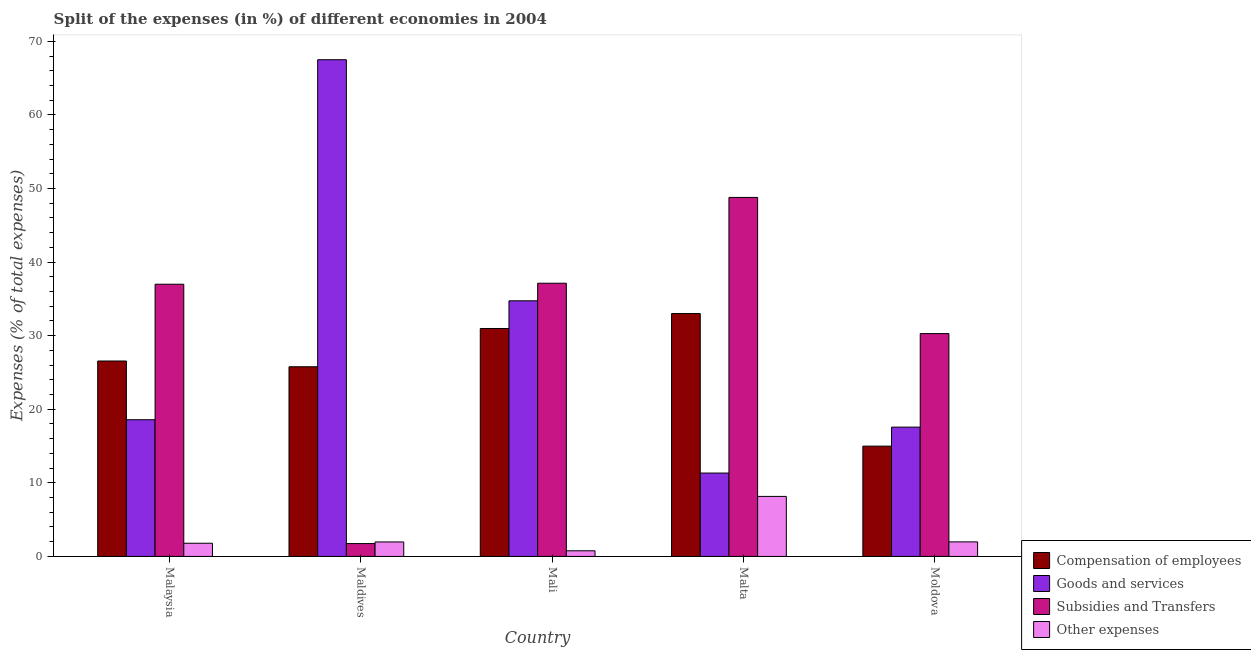How many different coloured bars are there?
Make the answer very short. 4. How many groups of bars are there?
Your response must be concise. 5. Are the number of bars on each tick of the X-axis equal?
Offer a terse response. Yes. How many bars are there on the 5th tick from the left?
Make the answer very short. 4. What is the label of the 3rd group of bars from the left?
Your answer should be very brief. Mali. In how many cases, is the number of bars for a given country not equal to the number of legend labels?
Offer a terse response. 0. What is the percentage of amount spent on other expenses in Malta?
Your response must be concise. 8.16. Across all countries, what is the maximum percentage of amount spent on goods and services?
Make the answer very short. 67.5. Across all countries, what is the minimum percentage of amount spent on other expenses?
Keep it short and to the point. 0.77. In which country was the percentage of amount spent on other expenses maximum?
Ensure brevity in your answer.  Malta. In which country was the percentage of amount spent on goods and services minimum?
Your answer should be compact. Malta. What is the total percentage of amount spent on subsidies in the graph?
Offer a terse response. 154.94. What is the difference between the percentage of amount spent on goods and services in Malaysia and that in Moldova?
Make the answer very short. 1. What is the difference between the percentage of amount spent on compensation of employees in Moldova and the percentage of amount spent on subsidies in Malta?
Give a very brief answer. -33.8. What is the average percentage of amount spent on other expenses per country?
Offer a terse response. 2.93. What is the difference between the percentage of amount spent on compensation of employees and percentage of amount spent on other expenses in Mali?
Your response must be concise. 30.21. In how many countries, is the percentage of amount spent on goods and services greater than 12 %?
Provide a short and direct response. 4. What is the ratio of the percentage of amount spent on goods and services in Maldives to that in Moldova?
Your answer should be compact. 3.84. Is the difference between the percentage of amount spent on compensation of employees in Maldives and Mali greater than the difference between the percentage of amount spent on goods and services in Maldives and Mali?
Provide a short and direct response. No. What is the difference between the highest and the second highest percentage of amount spent on compensation of employees?
Your response must be concise. 2.03. What is the difference between the highest and the lowest percentage of amount spent on goods and services?
Your answer should be compact. 56.17. What does the 1st bar from the left in Moldova represents?
Give a very brief answer. Compensation of employees. What does the 3rd bar from the right in Mali represents?
Give a very brief answer. Goods and services. How many bars are there?
Keep it short and to the point. 20. Does the graph contain any zero values?
Make the answer very short. No. How many legend labels are there?
Make the answer very short. 4. How are the legend labels stacked?
Offer a very short reply. Vertical. What is the title of the graph?
Your response must be concise. Split of the expenses (in %) of different economies in 2004. What is the label or title of the X-axis?
Keep it short and to the point. Country. What is the label or title of the Y-axis?
Offer a terse response. Expenses (% of total expenses). What is the Expenses (% of total expenses) in Compensation of employees in Malaysia?
Your answer should be compact. 26.56. What is the Expenses (% of total expenses) in Goods and services in Malaysia?
Offer a very short reply. 18.58. What is the Expenses (% of total expenses) in Subsidies and Transfers in Malaysia?
Provide a short and direct response. 36.99. What is the Expenses (% of total expenses) of Other expenses in Malaysia?
Make the answer very short. 1.79. What is the Expenses (% of total expenses) in Compensation of employees in Maldives?
Offer a terse response. 25.78. What is the Expenses (% of total expenses) in Goods and services in Maldives?
Keep it short and to the point. 67.5. What is the Expenses (% of total expenses) of Subsidies and Transfers in Maldives?
Provide a short and direct response. 1.75. What is the Expenses (% of total expenses) in Other expenses in Maldives?
Offer a very short reply. 1.97. What is the Expenses (% of total expenses) of Compensation of employees in Mali?
Offer a very short reply. 30.98. What is the Expenses (% of total expenses) in Goods and services in Mali?
Provide a short and direct response. 34.74. What is the Expenses (% of total expenses) in Subsidies and Transfers in Mali?
Provide a succinct answer. 37.13. What is the Expenses (% of total expenses) of Other expenses in Mali?
Keep it short and to the point. 0.77. What is the Expenses (% of total expenses) of Compensation of employees in Malta?
Your answer should be very brief. 33.01. What is the Expenses (% of total expenses) in Goods and services in Malta?
Offer a terse response. 11.33. What is the Expenses (% of total expenses) in Subsidies and Transfers in Malta?
Keep it short and to the point. 48.79. What is the Expenses (% of total expenses) of Other expenses in Malta?
Your answer should be compact. 8.16. What is the Expenses (% of total expenses) of Compensation of employees in Moldova?
Give a very brief answer. 14.99. What is the Expenses (% of total expenses) in Goods and services in Moldova?
Offer a terse response. 17.57. What is the Expenses (% of total expenses) of Subsidies and Transfers in Moldova?
Keep it short and to the point. 30.29. What is the Expenses (% of total expenses) of Other expenses in Moldova?
Keep it short and to the point. 1.98. Across all countries, what is the maximum Expenses (% of total expenses) of Compensation of employees?
Your answer should be compact. 33.01. Across all countries, what is the maximum Expenses (% of total expenses) in Goods and services?
Your response must be concise. 67.5. Across all countries, what is the maximum Expenses (% of total expenses) in Subsidies and Transfers?
Your answer should be very brief. 48.79. Across all countries, what is the maximum Expenses (% of total expenses) in Other expenses?
Keep it short and to the point. 8.16. Across all countries, what is the minimum Expenses (% of total expenses) of Compensation of employees?
Provide a succinct answer. 14.99. Across all countries, what is the minimum Expenses (% of total expenses) in Goods and services?
Ensure brevity in your answer.  11.33. Across all countries, what is the minimum Expenses (% of total expenses) of Subsidies and Transfers?
Give a very brief answer. 1.75. Across all countries, what is the minimum Expenses (% of total expenses) in Other expenses?
Give a very brief answer. 0.77. What is the total Expenses (% of total expenses) of Compensation of employees in the graph?
Give a very brief answer. 131.31. What is the total Expenses (% of total expenses) of Goods and services in the graph?
Your answer should be very brief. 149.73. What is the total Expenses (% of total expenses) of Subsidies and Transfers in the graph?
Provide a short and direct response. 154.94. What is the total Expenses (% of total expenses) of Other expenses in the graph?
Provide a short and direct response. 14.66. What is the difference between the Expenses (% of total expenses) of Compensation of employees in Malaysia and that in Maldives?
Keep it short and to the point. 0.78. What is the difference between the Expenses (% of total expenses) of Goods and services in Malaysia and that in Maldives?
Provide a short and direct response. -48.93. What is the difference between the Expenses (% of total expenses) of Subsidies and Transfers in Malaysia and that in Maldives?
Your response must be concise. 35.25. What is the difference between the Expenses (% of total expenses) in Other expenses in Malaysia and that in Maldives?
Offer a terse response. -0.18. What is the difference between the Expenses (% of total expenses) of Compensation of employees in Malaysia and that in Mali?
Make the answer very short. -4.42. What is the difference between the Expenses (% of total expenses) of Goods and services in Malaysia and that in Mali?
Provide a short and direct response. -16.16. What is the difference between the Expenses (% of total expenses) in Subsidies and Transfers in Malaysia and that in Mali?
Provide a succinct answer. -0.14. What is the difference between the Expenses (% of total expenses) of Other expenses in Malaysia and that in Mali?
Offer a very short reply. 1.02. What is the difference between the Expenses (% of total expenses) of Compensation of employees in Malaysia and that in Malta?
Give a very brief answer. -6.45. What is the difference between the Expenses (% of total expenses) of Goods and services in Malaysia and that in Malta?
Offer a very short reply. 7.25. What is the difference between the Expenses (% of total expenses) of Subsidies and Transfers in Malaysia and that in Malta?
Provide a short and direct response. -11.8. What is the difference between the Expenses (% of total expenses) in Other expenses in Malaysia and that in Malta?
Provide a succinct answer. -6.36. What is the difference between the Expenses (% of total expenses) of Compensation of employees in Malaysia and that in Moldova?
Your answer should be compact. 11.57. What is the difference between the Expenses (% of total expenses) in Subsidies and Transfers in Malaysia and that in Moldova?
Ensure brevity in your answer.  6.71. What is the difference between the Expenses (% of total expenses) of Other expenses in Malaysia and that in Moldova?
Give a very brief answer. -0.18. What is the difference between the Expenses (% of total expenses) of Goods and services in Maldives and that in Mali?
Provide a succinct answer. 32.76. What is the difference between the Expenses (% of total expenses) in Subsidies and Transfers in Maldives and that in Mali?
Offer a very short reply. -35.38. What is the difference between the Expenses (% of total expenses) in Other expenses in Maldives and that in Mali?
Provide a short and direct response. 1.2. What is the difference between the Expenses (% of total expenses) in Compensation of employees in Maldives and that in Malta?
Your answer should be compact. -7.23. What is the difference between the Expenses (% of total expenses) of Goods and services in Maldives and that in Malta?
Offer a terse response. 56.17. What is the difference between the Expenses (% of total expenses) of Subsidies and Transfers in Maldives and that in Malta?
Offer a very short reply. -47.04. What is the difference between the Expenses (% of total expenses) of Other expenses in Maldives and that in Malta?
Your answer should be compact. -6.19. What is the difference between the Expenses (% of total expenses) of Compensation of employees in Maldives and that in Moldova?
Make the answer very short. 10.79. What is the difference between the Expenses (% of total expenses) of Goods and services in Maldives and that in Moldova?
Give a very brief answer. 49.93. What is the difference between the Expenses (% of total expenses) of Subsidies and Transfers in Maldives and that in Moldova?
Ensure brevity in your answer.  -28.54. What is the difference between the Expenses (% of total expenses) in Other expenses in Maldives and that in Moldova?
Your response must be concise. -0.01. What is the difference between the Expenses (% of total expenses) in Compensation of employees in Mali and that in Malta?
Your answer should be very brief. -2.03. What is the difference between the Expenses (% of total expenses) in Goods and services in Mali and that in Malta?
Keep it short and to the point. 23.41. What is the difference between the Expenses (% of total expenses) in Subsidies and Transfers in Mali and that in Malta?
Make the answer very short. -11.66. What is the difference between the Expenses (% of total expenses) of Other expenses in Mali and that in Malta?
Ensure brevity in your answer.  -7.39. What is the difference between the Expenses (% of total expenses) in Compensation of employees in Mali and that in Moldova?
Make the answer very short. 15.99. What is the difference between the Expenses (% of total expenses) in Goods and services in Mali and that in Moldova?
Your response must be concise. 17.17. What is the difference between the Expenses (% of total expenses) in Subsidies and Transfers in Mali and that in Moldova?
Your answer should be very brief. 6.84. What is the difference between the Expenses (% of total expenses) in Other expenses in Mali and that in Moldova?
Provide a short and direct response. -1.21. What is the difference between the Expenses (% of total expenses) of Compensation of employees in Malta and that in Moldova?
Offer a terse response. 18.02. What is the difference between the Expenses (% of total expenses) of Goods and services in Malta and that in Moldova?
Your answer should be compact. -6.24. What is the difference between the Expenses (% of total expenses) in Subsidies and Transfers in Malta and that in Moldova?
Offer a very short reply. 18.5. What is the difference between the Expenses (% of total expenses) of Other expenses in Malta and that in Moldova?
Make the answer very short. 6.18. What is the difference between the Expenses (% of total expenses) in Compensation of employees in Malaysia and the Expenses (% of total expenses) in Goods and services in Maldives?
Make the answer very short. -40.95. What is the difference between the Expenses (% of total expenses) of Compensation of employees in Malaysia and the Expenses (% of total expenses) of Subsidies and Transfers in Maldives?
Your answer should be very brief. 24.81. What is the difference between the Expenses (% of total expenses) in Compensation of employees in Malaysia and the Expenses (% of total expenses) in Other expenses in Maldives?
Give a very brief answer. 24.59. What is the difference between the Expenses (% of total expenses) of Goods and services in Malaysia and the Expenses (% of total expenses) of Subsidies and Transfers in Maldives?
Give a very brief answer. 16.83. What is the difference between the Expenses (% of total expenses) in Goods and services in Malaysia and the Expenses (% of total expenses) in Other expenses in Maldives?
Provide a short and direct response. 16.61. What is the difference between the Expenses (% of total expenses) of Subsidies and Transfers in Malaysia and the Expenses (% of total expenses) of Other expenses in Maldives?
Keep it short and to the point. 35.02. What is the difference between the Expenses (% of total expenses) in Compensation of employees in Malaysia and the Expenses (% of total expenses) in Goods and services in Mali?
Give a very brief answer. -8.18. What is the difference between the Expenses (% of total expenses) of Compensation of employees in Malaysia and the Expenses (% of total expenses) of Subsidies and Transfers in Mali?
Provide a short and direct response. -10.57. What is the difference between the Expenses (% of total expenses) of Compensation of employees in Malaysia and the Expenses (% of total expenses) of Other expenses in Mali?
Ensure brevity in your answer.  25.79. What is the difference between the Expenses (% of total expenses) in Goods and services in Malaysia and the Expenses (% of total expenses) in Subsidies and Transfers in Mali?
Make the answer very short. -18.55. What is the difference between the Expenses (% of total expenses) of Goods and services in Malaysia and the Expenses (% of total expenses) of Other expenses in Mali?
Your answer should be compact. 17.81. What is the difference between the Expenses (% of total expenses) of Subsidies and Transfers in Malaysia and the Expenses (% of total expenses) of Other expenses in Mali?
Provide a short and direct response. 36.22. What is the difference between the Expenses (% of total expenses) in Compensation of employees in Malaysia and the Expenses (% of total expenses) in Goods and services in Malta?
Keep it short and to the point. 15.23. What is the difference between the Expenses (% of total expenses) in Compensation of employees in Malaysia and the Expenses (% of total expenses) in Subsidies and Transfers in Malta?
Offer a very short reply. -22.23. What is the difference between the Expenses (% of total expenses) of Compensation of employees in Malaysia and the Expenses (% of total expenses) of Other expenses in Malta?
Make the answer very short. 18.4. What is the difference between the Expenses (% of total expenses) of Goods and services in Malaysia and the Expenses (% of total expenses) of Subsidies and Transfers in Malta?
Keep it short and to the point. -30.21. What is the difference between the Expenses (% of total expenses) in Goods and services in Malaysia and the Expenses (% of total expenses) in Other expenses in Malta?
Your answer should be compact. 10.42. What is the difference between the Expenses (% of total expenses) in Subsidies and Transfers in Malaysia and the Expenses (% of total expenses) in Other expenses in Malta?
Offer a terse response. 28.84. What is the difference between the Expenses (% of total expenses) of Compensation of employees in Malaysia and the Expenses (% of total expenses) of Goods and services in Moldova?
Offer a terse response. 8.98. What is the difference between the Expenses (% of total expenses) of Compensation of employees in Malaysia and the Expenses (% of total expenses) of Subsidies and Transfers in Moldova?
Offer a terse response. -3.73. What is the difference between the Expenses (% of total expenses) of Compensation of employees in Malaysia and the Expenses (% of total expenses) of Other expenses in Moldova?
Provide a succinct answer. 24.58. What is the difference between the Expenses (% of total expenses) of Goods and services in Malaysia and the Expenses (% of total expenses) of Subsidies and Transfers in Moldova?
Offer a very short reply. -11.71. What is the difference between the Expenses (% of total expenses) in Goods and services in Malaysia and the Expenses (% of total expenses) in Other expenses in Moldova?
Your answer should be compact. 16.6. What is the difference between the Expenses (% of total expenses) in Subsidies and Transfers in Malaysia and the Expenses (% of total expenses) in Other expenses in Moldova?
Make the answer very short. 35.02. What is the difference between the Expenses (% of total expenses) in Compensation of employees in Maldives and the Expenses (% of total expenses) in Goods and services in Mali?
Offer a terse response. -8.96. What is the difference between the Expenses (% of total expenses) in Compensation of employees in Maldives and the Expenses (% of total expenses) in Subsidies and Transfers in Mali?
Offer a very short reply. -11.35. What is the difference between the Expenses (% of total expenses) in Compensation of employees in Maldives and the Expenses (% of total expenses) in Other expenses in Mali?
Your answer should be compact. 25.01. What is the difference between the Expenses (% of total expenses) of Goods and services in Maldives and the Expenses (% of total expenses) of Subsidies and Transfers in Mali?
Provide a succinct answer. 30.38. What is the difference between the Expenses (% of total expenses) of Goods and services in Maldives and the Expenses (% of total expenses) of Other expenses in Mali?
Offer a very short reply. 66.74. What is the difference between the Expenses (% of total expenses) of Subsidies and Transfers in Maldives and the Expenses (% of total expenses) of Other expenses in Mali?
Provide a short and direct response. 0.98. What is the difference between the Expenses (% of total expenses) in Compensation of employees in Maldives and the Expenses (% of total expenses) in Goods and services in Malta?
Make the answer very short. 14.45. What is the difference between the Expenses (% of total expenses) in Compensation of employees in Maldives and the Expenses (% of total expenses) in Subsidies and Transfers in Malta?
Your response must be concise. -23.01. What is the difference between the Expenses (% of total expenses) in Compensation of employees in Maldives and the Expenses (% of total expenses) in Other expenses in Malta?
Your answer should be very brief. 17.62. What is the difference between the Expenses (% of total expenses) of Goods and services in Maldives and the Expenses (% of total expenses) of Subsidies and Transfers in Malta?
Make the answer very short. 18.72. What is the difference between the Expenses (% of total expenses) of Goods and services in Maldives and the Expenses (% of total expenses) of Other expenses in Malta?
Keep it short and to the point. 59.35. What is the difference between the Expenses (% of total expenses) of Subsidies and Transfers in Maldives and the Expenses (% of total expenses) of Other expenses in Malta?
Give a very brief answer. -6.41. What is the difference between the Expenses (% of total expenses) in Compensation of employees in Maldives and the Expenses (% of total expenses) in Goods and services in Moldova?
Offer a very short reply. 8.2. What is the difference between the Expenses (% of total expenses) in Compensation of employees in Maldives and the Expenses (% of total expenses) in Subsidies and Transfers in Moldova?
Make the answer very short. -4.51. What is the difference between the Expenses (% of total expenses) in Compensation of employees in Maldives and the Expenses (% of total expenses) in Other expenses in Moldova?
Ensure brevity in your answer.  23.8. What is the difference between the Expenses (% of total expenses) of Goods and services in Maldives and the Expenses (% of total expenses) of Subsidies and Transfers in Moldova?
Make the answer very short. 37.22. What is the difference between the Expenses (% of total expenses) of Goods and services in Maldives and the Expenses (% of total expenses) of Other expenses in Moldova?
Give a very brief answer. 65.53. What is the difference between the Expenses (% of total expenses) in Subsidies and Transfers in Maldives and the Expenses (% of total expenses) in Other expenses in Moldova?
Your answer should be compact. -0.23. What is the difference between the Expenses (% of total expenses) of Compensation of employees in Mali and the Expenses (% of total expenses) of Goods and services in Malta?
Make the answer very short. 19.65. What is the difference between the Expenses (% of total expenses) of Compensation of employees in Mali and the Expenses (% of total expenses) of Subsidies and Transfers in Malta?
Keep it short and to the point. -17.81. What is the difference between the Expenses (% of total expenses) in Compensation of employees in Mali and the Expenses (% of total expenses) in Other expenses in Malta?
Offer a very short reply. 22.82. What is the difference between the Expenses (% of total expenses) in Goods and services in Mali and the Expenses (% of total expenses) in Subsidies and Transfers in Malta?
Provide a short and direct response. -14.05. What is the difference between the Expenses (% of total expenses) of Goods and services in Mali and the Expenses (% of total expenses) of Other expenses in Malta?
Make the answer very short. 26.58. What is the difference between the Expenses (% of total expenses) of Subsidies and Transfers in Mali and the Expenses (% of total expenses) of Other expenses in Malta?
Offer a terse response. 28.97. What is the difference between the Expenses (% of total expenses) in Compensation of employees in Mali and the Expenses (% of total expenses) in Goods and services in Moldova?
Keep it short and to the point. 13.4. What is the difference between the Expenses (% of total expenses) of Compensation of employees in Mali and the Expenses (% of total expenses) of Subsidies and Transfers in Moldova?
Provide a short and direct response. 0.69. What is the difference between the Expenses (% of total expenses) in Compensation of employees in Mali and the Expenses (% of total expenses) in Other expenses in Moldova?
Your answer should be compact. 29. What is the difference between the Expenses (% of total expenses) of Goods and services in Mali and the Expenses (% of total expenses) of Subsidies and Transfers in Moldova?
Provide a short and direct response. 4.45. What is the difference between the Expenses (% of total expenses) in Goods and services in Mali and the Expenses (% of total expenses) in Other expenses in Moldova?
Provide a short and direct response. 32.76. What is the difference between the Expenses (% of total expenses) of Subsidies and Transfers in Mali and the Expenses (% of total expenses) of Other expenses in Moldova?
Make the answer very short. 35.15. What is the difference between the Expenses (% of total expenses) of Compensation of employees in Malta and the Expenses (% of total expenses) of Goods and services in Moldova?
Your answer should be very brief. 15.44. What is the difference between the Expenses (% of total expenses) in Compensation of employees in Malta and the Expenses (% of total expenses) in Subsidies and Transfers in Moldova?
Give a very brief answer. 2.72. What is the difference between the Expenses (% of total expenses) of Compensation of employees in Malta and the Expenses (% of total expenses) of Other expenses in Moldova?
Your response must be concise. 31.03. What is the difference between the Expenses (% of total expenses) of Goods and services in Malta and the Expenses (% of total expenses) of Subsidies and Transfers in Moldova?
Provide a succinct answer. -18.95. What is the difference between the Expenses (% of total expenses) of Goods and services in Malta and the Expenses (% of total expenses) of Other expenses in Moldova?
Provide a succinct answer. 9.36. What is the difference between the Expenses (% of total expenses) of Subsidies and Transfers in Malta and the Expenses (% of total expenses) of Other expenses in Moldova?
Your response must be concise. 46.81. What is the average Expenses (% of total expenses) in Compensation of employees per country?
Give a very brief answer. 26.26. What is the average Expenses (% of total expenses) in Goods and services per country?
Ensure brevity in your answer.  29.95. What is the average Expenses (% of total expenses) in Subsidies and Transfers per country?
Make the answer very short. 30.99. What is the average Expenses (% of total expenses) of Other expenses per country?
Keep it short and to the point. 2.93. What is the difference between the Expenses (% of total expenses) in Compensation of employees and Expenses (% of total expenses) in Goods and services in Malaysia?
Give a very brief answer. 7.98. What is the difference between the Expenses (% of total expenses) of Compensation of employees and Expenses (% of total expenses) of Subsidies and Transfers in Malaysia?
Offer a terse response. -10.43. What is the difference between the Expenses (% of total expenses) in Compensation of employees and Expenses (% of total expenses) in Other expenses in Malaysia?
Provide a short and direct response. 24.77. What is the difference between the Expenses (% of total expenses) in Goods and services and Expenses (% of total expenses) in Subsidies and Transfers in Malaysia?
Offer a terse response. -18.41. What is the difference between the Expenses (% of total expenses) in Goods and services and Expenses (% of total expenses) in Other expenses in Malaysia?
Ensure brevity in your answer.  16.79. What is the difference between the Expenses (% of total expenses) of Subsidies and Transfers and Expenses (% of total expenses) of Other expenses in Malaysia?
Offer a terse response. 35.2. What is the difference between the Expenses (% of total expenses) of Compensation of employees and Expenses (% of total expenses) of Goods and services in Maldives?
Offer a very short reply. -41.73. What is the difference between the Expenses (% of total expenses) in Compensation of employees and Expenses (% of total expenses) in Subsidies and Transfers in Maldives?
Offer a very short reply. 24.03. What is the difference between the Expenses (% of total expenses) of Compensation of employees and Expenses (% of total expenses) of Other expenses in Maldives?
Keep it short and to the point. 23.81. What is the difference between the Expenses (% of total expenses) in Goods and services and Expenses (% of total expenses) in Subsidies and Transfers in Maldives?
Make the answer very short. 65.76. What is the difference between the Expenses (% of total expenses) in Goods and services and Expenses (% of total expenses) in Other expenses in Maldives?
Your answer should be compact. 65.54. What is the difference between the Expenses (% of total expenses) of Subsidies and Transfers and Expenses (% of total expenses) of Other expenses in Maldives?
Provide a short and direct response. -0.22. What is the difference between the Expenses (% of total expenses) in Compensation of employees and Expenses (% of total expenses) in Goods and services in Mali?
Provide a short and direct response. -3.76. What is the difference between the Expenses (% of total expenses) in Compensation of employees and Expenses (% of total expenses) in Subsidies and Transfers in Mali?
Offer a very short reply. -6.15. What is the difference between the Expenses (% of total expenses) of Compensation of employees and Expenses (% of total expenses) of Other expenses in Mali?
Your response must be concise. 30.21. What is the difference between the Expenses (% of total expenses) of Goods and services and Expenses (% of total expenses) of Subsidies and Transfers in Mali?
Your answer should be very brief. -2.39. What is the difference between the Expenses (% of total expenses) in Goods and services and Expenses (% of total expenses) in Other expenses in Mali?
Your response must be concise. 33.97. What is the difference between the Expenses (% of total expenses) in Subsidies and Transfers and Expenses (% of total expenses) in Other expenses in Mali?
Provide a short and direct response. 36.36. What is the difference between the Expenses (% of total expenses) of Compensation of employees and Expenses (% of total expenses) of Goods and services in Malta?
Your response must be concise. 21.68. What is the difference between the Expenses (% of total expenses) of Compensation of employees and Expenses (% of total expenses) of Subsidies and Transfers in Malta?
Your answer should be very brief. -15.78. What is the difference between the Expenses (% of total expenses) of Compensation of employees and Expenses (% of total expenses) of Other expenses in Malta?
Keep it short and to the point. 24.85. What is the difference between the Expenses (% of total expenses) of Goods and services and Expenses (% of total expenses) of Subsidies and Transfers in Malta?
Your answer should be very brief. -37.46. What is the difference between the Expenses (% of total expenses) in Goods and services and Expenses (% of total expenses) in Other expenses in Malta?
Offer a terse response. 3.18. What is the difference between the Expenses (% of total expenses) in Subsidies and Transfers and Expenses (% of total expenses) in Other expenses in Malta?
Your response must be concise. 40.63. What is the difference between the Expenses (% of total expenses) in Compensation of employees and Expenses (% of total expenses) in Goods and services in Moldova?
Offer a terse response. -2.58. What is the difference between the Expenses (% of total expenses) of Compensation of employees and Expenses (% of total expenses) of Subsidies and Transfers in Moldova?
Provide a short and direct response. -15.3. What is the difference between the Expenses (% of total expenses) in Compensation of employees and Expenses (% of total expenses) in Other expenses in Moldova?
Offer a terse response. 13.01. What is the difference between the Expenses (% of total expenses) of Goods and services and Expenses (% of total expenses) of Subsidies and Transfers in Moldova?
Offer a terse response. -12.71. What is the difference between the Expenses (% of total expenses) in Goods and services and Expenses (% of total expenses) in Other expenses in Moldova?
Offer a very short reply. 15.6. What is the difference between the Expenses (% of total expenses) in Subsidies and Transfers and Expenses (% of total expenses) in Other expenses in Moldova?
Your answer should be very brief. 28.31. What is the ratio of the Expenses (% of total expenses) in Compensation of employees in Malaysia to that in Maldives?
Your answer should be compact. 1.03. What is the ratio of the Expenses (% of total expenses) in Goods and services in Malaysia to that in Maldives?
Keep it short and to the point. 0.28. What is the ratio of the Expenses (% of total expenses) of Subsidies and Transfers in Malaysia to that in Maldives?
Ensure brevity in your answer.  21.18. What is the ratio of the Expenses (% of total expenses) of Other expenses in Malaysia to that in Maldives?
Offer a very short reply. 0.91. What is the ratio of the Expenses (% of total expenses) in Compensation of employees in Malaysia to that in Mali?
Your answer should be compact. 0.86. What is the ratio of the Expenses (% of total expenses) in Goods and services in Malaysia to that in Mali?
Provide a short and direct response. 0.53. What is the ratio of the Expenses (% of total expenses) of Subsidies and Transfers in Malaysia to that in Mali?
Your response must be concise. 1. What is the ratio of the Expenses (% of total expenses) of Other expenses in Malaysia to that in Mali?
Keep it short and to the point. 2.33. What is the ratio of the Expenses (% of total expenses) of Compensation of employees in Malaysia to that in Malta?
Your answer should be compact. 0.8. What is the ratio of the Expenses (% of total expenses) in Goods and services in Malaysia to that in Malta?
Keep it short and to the point. 1.64. What is the ratio of the Expenses (% of total expenses) in Subsidies and Transfers in Malaysia to that in Malta?
Your answer should be very brief. 0.76. What is the ratio of the Expenses (% of total expenses) of Other expenses in Malaysia to that in Malta?
Your answer should be very brief. 0.22. What is the ratio of the Expenses (% of total expenses) of Compensation of employees in Malaysia to that in Moldova?
Your response must be concise. 1.77. What is the ratio of the Expenses (% of total expenses) of Goods and services in Malaysia to that in Moldova?
Make the answer very short. 1.06. What is the ratio of the Expenses (% of total expenses) of Subsidies and Transfers in Malaysia to that in Moldova?
Give a very brief answer. 1.22. What is the ratio of the Expenses (% of total expenses) in Other expenses in Malaysia to that in Moldova?
Keep it short and to the point. 0.91. What is the ratio of the Expenses (% of total expenses) of Compensation of employees in Maldives to that in Mali?
Give a very brief answer. 0.83. What is the ratio of the Expenses (% of total expenses) of Goods and services in Maldives to that in Mali?
Provide a short and direct response. 1.94. What is the ratio of the Expenses (% of total expenses) in Subsidies and Transfers in Maldives to that in Mali?
Keep it short and to the point. 0.05. What is the ratio of the Expenses (% of total expenses) in Other expenses in Maldives to that in Mali?
Keep it short and to the point. 2.57. What is the ratio of the Expenses (% of total expenses) of Compensation of employees in Maldives to that in Malta?
Provide a succinct answer. 0.78. What is the ratio of the Expenses (% of total expenses) of Goods and services in Maldives to that in Malta?
Give a very brief answer. 5.96. What is the ratio of the Expenses (% of total expenses) in Subsidies and Transfers in Maldives to that in Malta?
Provide a succinct answer. 0.04. What is the ratio of the Expenses (% of total expenses) in Other expenses in Maldives to that in Malta?
Your answer should be very brief. 0.24. What is the ratio of the Expenses (% of total expenses) of Compensation of employees in Maldives to that in Moldova?
Provide a succinct answer. 1.72. What is the ratio of the Expenses (% of total expenses) in Goods and services in Maldives to that in Moldova?
Ensure brevity in your answer.  3.84. What is the ratio of the Expenses (% of total expenses) in Subsidies and Transfers in Maldives to that in Moldova?
Your answer should be very brief. 0.06. What is the ratio of the Expenses (% of total expenses) of Compensation of employees in Mali to that in Malta?
Give a very brief answer. 0.94. What is the ratio of the Expenses (% of total expenses) in Goods and services in Mali to that in Malta?
Keep it short and to the point. 3.07. What is the ratio of the Expenses (% of total expenses) of Subsidies and Transfers in Mali to that in Malta?
Ensure brevity in your answer.  0.76. What is the ratio of the Expenses (% of total expenses) in Other expenses in Mali to that in Malta?
Your answer should be very brief. 0.09. What is the ratio of the Expenses (% of total expenses) in Compensation of employees in Mali to that in Moldova?
Ensure brevity in your answer.  2.07. What is the ratio of the Expenses (% of total expenses) of Goods and services in Mali to that in Moldova?
Your answer should be very brief. 1.98. What is the ratio of the Expenses (% of total expenses) in Subsidies and Transfers in Mali to that in Moldova?
Provide a short and direct response. 1.23. What is the ratio of the Expenses (% of total expenses) of Other expenses in Mali to that in Moldova?
Your answer should be compact. 0.39. What is the ratio of the Expenses (% of total expenses) in Compensation of employees in Malta to that in Moldova?
Offer a very short reply. 2.2. What is the ratio of the Expenses (% of total expenses) of Goods and services in Malta to that in Moldova?
Give a very brief answer. 0.64. What is the ratio of the Expenses (% of total expenses) in Subsidies and Transfers in Malta to that in Moldova?
Make the answer very short. 1.61. What is the ratio of the Expenses (% of total expenses) in Other expenses in Malta to that in Moldova?
Provide a succinct answer. 4.13. What is the difference between the highest and the second highest Expenses (% of total expenses) of Compensation of employees?
Offer a very short reply. 2.03. What is the difference between the highest and the second highest Expenses (% of total expenses) in Goods and services?
Your response must be concise. 32.76. What is the difference between the highest and the second highest Expenses (% of total expenses) of Subsidies and Transfers?
Offer a very short reply. 11.66. What is the difference between the highest and the second highest Expenses (% of total expenses) of Other expenses?
Give a very brief answer. 6.18. What is the difference between the highest and the lowest Expenses (% of total expenses) in Compensation of employees?
Provide a short and direct response. 18.02. What is the difference between the highest and the lowest Expenses (% of total expenses) in Goods and services?
Ensure brevity in your answer.  56.17. What is the difference between the highest and the lowest Expenses (% of total expenses) of Subsidies and Transfers?
Your response must be concise. 47.04. What is the difference between the highest and the lowest Expenses (% of total expenses) in Other expenses?
Give a very brief answer. 7.39. 